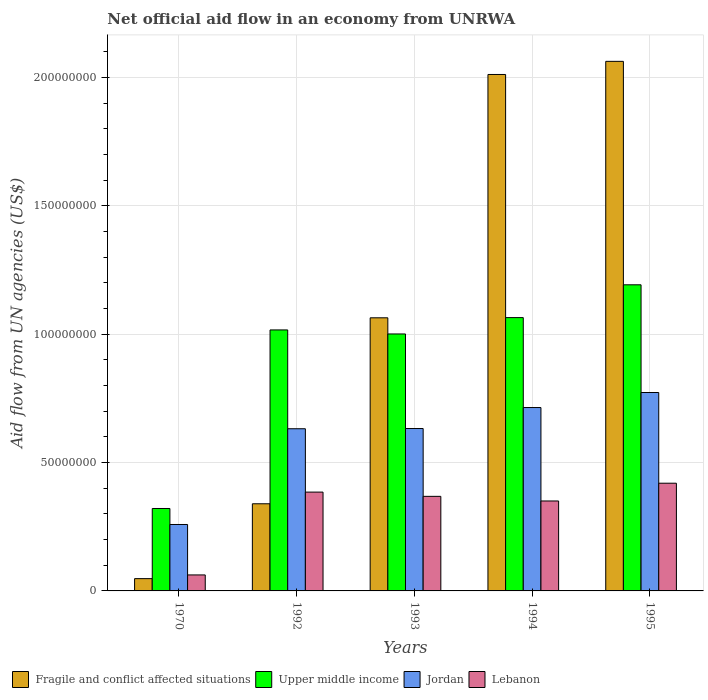Are the number of bars per tick equal to the number of legend labels?
Offer a very short reply. Yes. How many bars are there on the 4th tick from the right?
Provide a succinct answer. 4. What is the net official aid flow in Upper middle income in 1992?
Offer a terse response. 1.02e+08. Across all years, what is the maximum net official aid flow in Lebanon?
Offer a very short reply. 4.20e+07. Across all years, what is the minimum net official aid flow in Upper middle income?
Make the answer very short. 3.21e+07. In which year was the net official aid flow in Jordan maximum?
Provide a succinct answer. 1995. In which year was the net official aid flow in Jordan minimum?
Make the answer very short. 1970. What is the total net official aid flow in Fragile and conflict affected situations in the graph?
Make the answer very short. 5.53e+08. What is the difference between the net official aid flow in Lebanon in 1970 and that in 1992?
Your response must be concise. -3.23e+07. What is the difference between the net official aid flow in Upper middle income in 1970 and the net official aid flow in Jordan in 1995?
Give a very brief answer. -4.52e+07. What is the average net official aid flow in Fragile and conflict affected situations per year?
Offer a terse response. 1.11e+08. In the year 1993, what is the difference between the net official aid flow in Upper middle income and net official aid flow in Jordan?
Offer a terse response. 3.68e+07. What is the ratio of the net official aid flow in Upper middle income in 1970 to that in 1993?
Offer a terse response. 0.32. Is the difference between the net official aid flow in Upper middle income in 1993 and 1995 greater than the difference between the net official aid flow in Jordan in 1993 and 1995?
Offer a terse response. No. What is the difference between the highest and the second highest net official aid flow in Fragile and conflict affected situations?
Give a very brief answer. 5.11e+06. What is the difference between the highest and the lowest net official aid flow in Lebanon?
Ensure brevity in your answer.  3.57e+07. In how many years, is the net official aid flow in Fragile and conflict affected situations greater than the average net official aid flow in Fragile and conflict affected situations taken over all years?
Make the answer very short. 2. Is the sum of the net official aid flow in Upper middle income in 1994 and 1995 greater than the maximum net official aid flow in Lebanon across all years?
Your answer should be compact. Yes. What does the 3rd bar from the left in 1992 represents?
Offer a very short reply. Jordan. What does the 3rd bar from the right in 1994 represents?
Offer a very short reply. Upper middle income. How many bars are there?
Give a very brief answer. 20. Does the graph contain grids?
Your response must be concise. Yes. What is the title of the graph?
Your answer should be very brief. Net official aid flow in an economy from UNRWA. What is the label or title of the Y-axis?
Your response must be concise. Aid flow from UN agencies (US$). What is the Aid flow from UN agencies (US$) of Fragile and conflict affected situations in 1970?
Keep it short and to the point. 4.79e+06. What is the Aid flow from UN agencies (US$) of Upper middle income in 1970?
Offer a very short reply. 3.21e+07. What is the Aid flow from UN agencies (US$) of Jordan in 1970?
Offer a terse response. 2.59e+07. What is the Aid flow from UN agencies (US$) of Lebanon in 1970?
Your answer should be compact. 6.23e+06. What is the Aid flow from UN agencies (US$) in Fragile and conflict affected situations in 1992?
Offer a terse response. 3.40e+07. What is the Aid flow from UN agencies (US$) in Upper middle income in 1992?
Offer a very short reply. 1.02e+08. What is the Aid flow from UN agencies (US$) in Jordan in 1992?
Give a very brief answer. 6.32e+07. What is the Aid flow from UN agencies (US$) in Lebanon in 1992?
Offer a very short reply. 3.85e+07. What is the Aid flow from UN agencies (US$) in Fragile and conflict affected situations in 1993?
Your answer should be compact. 1.06e+08. What is the Aid flow from UN agencies (US$) of Upper middle income in 1993?
Keep it short and to the point. 1.00e+08. What is the Aid flow from UN agencies (US$) of Jordan in 1993?
Provide a short and direct response. 6.33e+07. What is the Aid flow from UN agencies (US$) in Lebanon in 1993?
Ensure brevity in your answer.  3.68e+07. What is the Aid flow from UN agencies (US$) of Fragile and conflict affected situations in 1994?
Your answer should be compact. 2.01e+08. What is the Aid flow from UN agencies (US$) of Upper middle income in 1994?
Offer a very short reply. 1.06e+08. What is the Aid flow from UN agencies (US$) of Jordan in 1994?
Keep it short and to the point. 7.14e+07. What is the Aid flow from UN agencies (US$) of Lebanon in 1994?
Offer a very short reply. 3.50e+07. What is the Aid flow from UN agencies (US$) in Fragile and conflict affected situations in 1995?
Offer a terse response. 2.06e+08. What is the Aid flow from UN agencies (US$) in Upper middle income in 1995?
Offer a terse response. 1.19e+08. What is the Aid flow from UN agencies (US$) in Jordan in 1995?
Make the answer very short. 7.73e+07. What is the Aid flow from UN agencies (US$) in Lebanon in 1995?
Your answer should be compact. 4.20e+07. Across all years, what is the maximum Aid flow from UN agencies (US$) of Fragile and conflict affected situations?
Your answer should be compact. 2.06e+08. Across all years, what is the maximum Aid flow from UN agencies (US$) of Upper middle income?
Provide a short and direct response. 1.19e+08. Across all years, what is the maximum Aid flow from UN agencies (US$) of Jordan?
Your answer should be very brief. 7.73e+07. Across all years, what is the maximum Aid flow from UN agencies (US$) of Lebanon?
Keep it short and to the point. 4.20e+07. Across all years, what is the minimum Aid flow from UN agencies (US$) in Fragile and conflict affected situations?
Ensure brevity in your answer.  4.79e+06. Across all years, what is the minimum Aid flow from UN agencies (US$) in Upper middle income?
Give a very brief answer. 3.21e+07. Across all years, what is the minimum Aid flow from UN agencies (US$) of Jordan?
Provide a short and direct response. 2.59e+07. Across all years, what is the minimum Aid flow from UN agencies (US$) of Lebanon?
Offer a terse response. 6.23e+06. What is the total Aid flow from UN agencies (US$) in Fragile and conflict affected situations in the graph?
Your answer should be very brief. 5.53e+08. What is the total Aid flow from UN agencies (US$) in Upper middle income in the graph?
Give a very brief answer. 4.60e+08. What is the total Aid flow from UN agencies (US$) in Jordan in the graph?
Your answer should be compact. 3.01e+08. What is the total Aid flow from UN agencies (US$) of Lebanon in the graph?
Give a very brief answer. 1.59e+08. What is the difference between the Aid flow from UN agencies (US$) in Fragile and conflict affected situations in 1970 and that in 1992?
Your response must be concise. -2.92e+07. What is the difference between the Aid flow from UN agencies (US$) of Upper middle income in 1970 and that in 1992?
Your answer should be compact. -6.96e+07. What is the difference between the Aid flow from UN agencies (US$) of Jordan in 1970 and that in 1992?
Ensure brevity in your answer.  -3.73e+07. What is the difference between the Aid flow from UN agencies (US$) of Lebanon in 1970 and that in 1992?
Make the answer very short. -3.23e+07. What is the difference between the Aid flow from UN agencies (US$) of Fragile and conflict affected situations in 1970 and that in 1993?
Offer a very short reply. -1.02e+08. What is the difference between the Aid flow from UN agencies (US$) of Upper middle income in 1970 and that in 1993?
Give a very brief answer. -6.80e+07. What is the difference between the Aid flow from UN agencies (US$) in Jordan in 1970 and that in 1993?
Your answer should be compact. -3.74e+07. What is the difference between the Aid flow from UN agencies (US$) of Lebanon in 1970 and that in 1993?
Ensure brevity in your answer.  -3.06e+07. What is the difference between the Aid flow from UN agencies (US$) in Fragile and conflict affected situations in 1970 and that in 1994?
Your response must be concise. -1.96e+08. What is the difference between the Aid flow from UN agencies (US$) in Upper middle income in 1970 and that in 1994?
Make the answer very short. -7.44e+07. What is the difference between the Aid flow from UN agencies (US$) in Jordan in 1970 and that in 1994?
Your answer should be very brief. -4.56e+07. What is the difference between the Aid flow from UN agencies (US$) in Lebanon in 1970 and that in 1994?
Ensure brevity in your answer.  -2.88e+07. What is the difference between the Aid flow from UN agencies (US$) of Fragile and conflict affected situations in 1970 and that in 1995?
Give a very brief answer. -2.02e+08. What is the difference between the Aid flow from UN agencies (US$) in Upper middle income in 1970 and that in 1995?
Provide a short and direct response. -8.72e+07. What is the difference between the Aid flow from UN agencies (US$) of Jordan in 1970 and that in 1995?
Offer a terse response. -5.14e+07. What is the difference between the Aid flow from UN agencies (US$) in Lebanon in 1970 and that in 1995?
Make the answer very short. -3.57e+07. What is the difference between the Aid flow from UN agencies (US$) in Fragile and conflict affected situations in 1992 and that in 1993?
Keep it short and to the point. -7.24e+07. What is the difference between the Aid flow from UN agencies (US$) of Upper middle income in 1992 and that in 1993?
Keep it short and to the point. 1.57e+06. What is the difference between the Aid flow from UN agencies (US$) of Jordan in 1992 and that in 1993?
Ensure brevity in your answer.  -9.00e+04. What is the difference between the Aid flow from UN agencies (US$) of Lebanon in 1992 and that in 1993?
Make the answer very short. 1.66e+06. What is the difference between the Aid flow from UN agencies (US$) in Fragile and conflict affected situations in 1992 and that in 1994?
Offer a terse response. -1.67e+08. What is the difference between the Aid flow from UN agencies (US$) of Upper middle income in 1992 and that in 1994?
Offer a very short reply. -4.80e+06. What is the difference between the Aid flow from UN agencies (US$) of Jordan in 1992 and that in 1994?
Make the answer very short. -8.26e+06. What is the difference between the Aid flow from UN agencies (US$) of Lebanon in 1992 and that in 1994?
Keep it short and to the point. 3.46e+06. What is the difference between the Aid flow from UN agencies (US$) in Fragile and conflict affected situations in 1992 and that in 1995?
Give a very brief answer. -1.72e+08. What is the difference between the Aid flow from UN agencies (US$) in Upper middle income in 1992 and that in 1995?
Ensure brevity in your answer.  -1.76e+07. What is the difference between the Aid flow from UN agencies (US$) in Jordan in 1992 and that in 1995?
Keep it short and to the point. -1.41e+07. What is the difference between the Aid flow from UN agencies (US$) of Lebanon in 1992 and that in 1995?
Your answer should be compact. -3.46e+06. What is the difference between the Aid flow from UN agencies (US$) in Fragile and conflict affected situations in 1993 and that in 1994?
Your response must be concise. -9.48e+07. What is the difference between the Aid flow from UN agencies (US$) in Upper middle income in 1993 and that in 1994?
Your answer should be compact. -6.37e+06. What is the difference between the Aid flow from UN agencies (US$) of Jordan in 1993 and that in 1994?
Your answer should be very brief. -8.17e+06. What is the difference between the Aid flow from UN agencies (US$) in Lebanon in 1993 and that in 1994?
Ensure brevity in your answer.  1.80e+06. What is the difference between the Aid flow from UN agencies (US$) of Fragile and conflict affected situations in 1993 and that in 1995?
Offer a very short reply. -9.99e+07. What is the difference between the Aid flow from UN agencies (US$) of Upper middle income in 1993 and that in 1995?
Make the answer very short. -1.92e+07. What is the difference between the Aid flow from UN agencies (US$) of Jordan in 1993 and that in 1995?
Give a very brief answer. -1.40e+07. What is the difference between the Aid flow from UN agencies (US$) of Lebanon in 1993 and that in 1995?
Offer a terse response. -5.12e+06. What is the difference between the Aid flow from UN agencies (US$) in Fragile and conflict affected situations in 1994 and that in 1995?
Provide a short and direct response. -5.11e+06. What is the difference between the Aid flow from UN agencies (US$) in Upper middle income in 1994 and that in 1995?
Provide a succinct answer. -1.28e+07. What is the difference between the Aid flow from UN agencies (US$) of Jordan in 1994 and that in 1995?
Make the answer very short. -5.86e+06. What is the difference between the Aid flow from UN agencies (US$) of Lebanon in 1994 and that in 1995?
Offer a terse response. -6.92e+06. What is the difference between the Aid flow from UN agencies (US$) in Fragile and conflict affected situations in 1970 and the Aid flow from UN agencies (US$) in Upper middle income in 1992?
Offer a terse response. -9.69e+07. What is the difference between the Aid flow from UN agencies (US$) in Fragile and conflict affected situations in 1970 and the Aid flow from UN agencies (US$) in Jordan in 1992?
Your answer should be compact. -5.84e+07. What is the difference between the Aid flow from UN agencies (US$) in Fragile and conflict affected situations in 1970 and the Aid flow from UN agencies (US$) in Lebanon in 1992?
Offer a terse response. -3.37e+07. What is the difference between the Aid flow from UN agencies (US$) of Upper middle income in 1970 and the Aid flow from UN agencies (US$) of Jordan in 1992?
Your answer should be very brief. -3.11e+07. What is the difference between the Aid flow from UN agencies (US$) of Upper middle income in 1970 and the Aid flow from UN agencies (US$) of Lebanon in 1992?
Offer a terse response. -6.39e+06. What is the difference between the Aid flow from UN agencies (US$) of Jordan in 1970 and the Aid flow from UN agencies (US$) of Lebanon in 1992?
Your answer should be compact. -1.26e+07. What is the difference between the Aid flow from UN agencies (US$) of Fragile and conflict affected situations in 1970 and the Aid flow from UN agencies (US$) of Upper middle income in 1993?
Provide a short and direct response. -9.53e+07. What is the difference between the Aid flow from UN agencies (US$) in Fragile and conflict affected situations in 1970 and the Aid flow from UN agencies (US$) in Jordan in 1993?
Your answer should be very brief. -5.85e+07. What is the difference between the Aid flow from UN agencies (US$) of Fragile and conflict affected situations in 1970 and the Aid flow from UN agencies (US$) of Lebanon in 1993?
Make the answer very short. -3.20e+07. What is the difference between the Aid flow from UN agencies (US$) in Upper middle income in 1970 and the Aid flow from UN agencies (US$) in Jordan in 1993?
Offer a terse response. -3.12e+07. What is the difference between the Aid flow from UN agencies (US$) in Upper middle income in 1970 and the Aid flow from UN agencies (US$) in Lebanon in 1993?
Keep it short and to the point. -4.73e+06. What is the difference between the Aid flow from UN agencies (US$) of Jordan in 1970 and the Aid flow from UN agencies (US$) of Lebanon in 1993?
Ensure brevity in your answer.  -1.10e+07. What is the difference between the Aid flow from UN agencies (US$) in Fragile and conflict affected situations in 1970 and the Aid flow from UN agencies (US$) in Upper middle income in 1994?
Provide a succinct answer. -1.02e+08. What is the difference between the Aid flow from UN agencies (US$) of Fragile and conflict affected situations in 1970 and the Aid flow from UN agencies (US$) of Jordan in 1994?
Provide a succinct answer. -6.66e+07. What is the difference between the Aid flow from UN agencies (US$) in Fragile and conflict affected situations in 1970 and the Aid flow from UN agencies (US$) in Lebanon in 1994?
Your answer should be compact. -3.02e+07. What is the difference between the Aid flow from UN agencies (US$) in Upper middle income in 1970 and the Aid flow from UN agencies (US$) in Jordan in 1994?
Make the answer very short. -3.93e+07. What is the difference between the Aid flow from UN agencies (US$) of Upper middle income in 1970 and the Aid flow from UN agencies (US$) of Lebanon in 1994?
Your answer should be compact. -2.93e+06. What is the difference between the Aid flow from UN agencies (US$) of Jordan in 1970 and the Aid flow from UN agencies (US$) of Lebanon in 1994?
Provide a short and direct response. -9.16e+06. What is the difference between the Aid flow from UN agencies (US$) of Fragile and conflict affected situations in 1970 and the Aid flow from UN agencies (US$) of Upper middle income in 1995?
Your answer should be very brief. -1.14e+08. What is the difference between the Aid flow from UN agencies (US$) of Fragile and conflict affected situations in 1970 and the Aid flow from UN agencies (US$) of Jordan in 1995?
Give a very brief answer. -7.25e+07. What is the difference between the Aid flow from UN agencies (US$) of Fragile and conflict affected situations in 1970 and the Aid flow from UN agencies (US$) of Lebanon in 1995?
Offer a very short reply. -3.72e+07. What is the difference between the Aid flow from UN agencies (US$) of Upper middle income in 1970 and the Aid flow from UN agencies (US$) of Jordan in 1995?
Offer a terse response. -4.52e+07. What is the difference between the Aid flow from UN agencies (US$) in Upper middle income in 1970 and the Aid flow from UN agencies (US$) in Lebanon in 1995?
Offer a very short reply. -9.85e+06. What is the difference between the Aid flow from UN agencies (US$) in Jordan in 1970 and the Aid flow from UN agencies (US$) in Lebanon in 1995?
Provide a short and direct response. -1.61e+07. What is the difference between the Aid flow from UN agencies (US$) of Fragile and conflict affected situations in 1992 and the Aid flow from UN agencies (US$) of Upper middle income in 1993?
Ensure brevity in your answer.  -6.62e+07. What is the difference between the Aid flow from UN agencies (US$) of Fragile and conflict affected situations in 1992 and the Aid flow from UN agencies (US$) of Jordan in 1993?
Make the answer very short. -2.93e+07. What is the difference between the Aid flow from UN agencies (US$) of Fragile and conflict affected situations in 1992 and the Aid flow from UN agencies (US$) of Lebanon in 1993?
Your answer should be compact. -2.89e+06. What is the difference between the Aid flow from UN agencies (US$) in Upper middle income in 1992 and the Aid flow from UN agencies (US$) in Jordan in 1993?
Provide a succinct answer. 3.84e+07. What is the difference between the Aid flow from UN agencies (US$) in Upper middle income in 1992 and the Aid flow from UN agencies (US$) in Lebanon in 1993?
Provide a short and direct response. 6.48e+07. What is the difference between the Aid flow from UN agencies (US$) of Jordan in 1992 and the Aid flow from UN agencies (US$) of Lebanon in 1993?
Provide a succinct answer. 2.63e+07. What is the difference between the Aid flow from UN agencies (US$) in Fragile and conflict affected situations in 1992 and the Aid flow from UN agencies (US$) in Upper middle income in 1994?
Provide a succinct answer. -7.25e+07. What is the difference between the Aid flow from UN agencies (US$) in Fragile and conflict affected situations in 1992 and the Aid flow from UN agencies (US$) in Jordan in 1994?
Make the answer very short. -3.75e+07. What is the difference between the Aid flow from UN agencies (US$) of Fragile and conflict affected situations in 1992 and the Aid flow from UN agencies (US$) of Lebanon in 1994?
Offer a terse response. -1.09e+06. What is the difference between the Aid flow from UN agencies (US$) in Upper middle income in 1992 and the Aid flow from UN agencies (US$) in Jordan in 1994?
Make the answer very short. 3.02e+07. What is the difference between the Aid flow from UN agencies (US$) in Upper middle income in 1992 and the Aid flow from UN agencies (US$) in Lebanon in 1994?
Provide a short and direct response. 6.66e+07. What is the difference between the Aid flow from UN agencies (US$) in Jordan in 1992 and the Aid flow from UN agencies (US$) in Lebanon in 1994?
Provide a succinct answer. 2.81e+07. What is the difference between the Aid flow from UN agencies (US$) in Fragile and conflict affected situations in 1992 and the Aid flow from UN agencies (US$) in Upper middle income in 1995?
Your answer should be very brief. -8.53e+07. What is the difference between the Aid flow from UN agencies (US$) in Fragile and conflict affected situations in 1992 and the Aid flow from UN agencies (US$) in Jordan in 1995?
Give a very brief answer. -4.34e+07. What is the difference between the Aid flow from UN agencies (US$) of Fragile and conflict affected situations in 1992 and the Aid flow from UN agencies (US$) of Lebanon in 1995?
Your answer should be compact. -8.01e+06. What is the difference between the Aid flow from UN agencies (US$) in Upper middle income in 1992 and the Aid flow from UN agencies (US$) in Jordan in 1995?
Keep it short and to the point. 2.44e+07. What is the difference between the Aid flow from UN agencies (US$) of Upper middle income in 1992 and the Aid flow from UN agencies (US$) of Lebanon in 1995?
Offer a terse response. 5.97e+07. What is the difference between the Aid flow from UN agencies (US$) of Jordan in 1992 and the Aid flow from UN agencies (US$) of Lebanon in 1995?
Keep it short and to the point. 2.12e+07. What is the difference between the Aid flow from UN agencies (US$) of Fragile and conflict affected situations in 1993 and the Aid flow from UN agencies (US$) of Upper middle income in 1994?
Give a very brief answer. -8.00e+04. What is the difference between the Aid flow from UN agencies (US$) of Fragile and conflict affected situations in 1993 and the Aid flow from UN agencies (US$) of Jordan in 1994?
Your answer should be very brief. 3.50e+07. What is the difference between the Aid flow from UN agencies (US$) of Fragile and conflict affected situations in 1993 and the Aid flow from UN agencies (US$) of Lebanon in 1994?
Provide a short and direct response. 7.14e+07. What is the difference between the Aid flow from UN agencies (US$) of Upper middle income in 1993 and the Aid flow from UN agencies (US$) of Jordan in 1994?
Your response must be concise. 2.87e+07. What is the difference between the Aid flow from UN agencies (US$) of Upper middle income in 1993 and the Aid flow from UN agencies (US$) of Lebanon in 1994?
Your answer should be compact. 6.51e+07. What is the difference between the Aid flow from UN agencies (US$) in Jordan in 1993 and the Aid flow from UN agencies (US$) in Lebanon in 1994?
Your answer should be compact. 2.82e+07. What is the difference between the Aid flow from UN agencies (US$) of Fragile and conflict affected situations in 1993 and the Aid flow from UN agencies (US$) of Upper middle income in 1995?
Offer a very short reply. -1.29e+07. What is the difference between the Aid flow from UN agencies (US$) of Fragile and conflict affected situations in 1993 and the Aid flow from UN agencies (US$) of Jordan in 1995?
Give a very brief answer. 2.91e+07. What is the difference between the Aid flow from UN agencies (US$) of Fragile and conflict affected situations in 1993 and the Aid flow from UN agencies (US$) of Lebanon in 1995?
Keep it short and to the point. 6.44e+07. What is the difference between the Aid flow from UN agencies (US$) of Upper middle income in 1993 and the Aid flow from UN agencies (US$) of Jordan in 1995?
Ensure brevity in your answer.  2.28e+07. What is the difference between the Aid flow from UN agencies (US$) of Upper middle income in 1993 and the Aid flow from UN agencies (US$) of Lebanon in 1995?
Keep it short and to the point. 5.82e+07. What is the difference between the Aid flow from UN agencies (US$) of Jordan in 1993 and the Aid flow from UN agencies (US$) of Lebanon in 1995?
Provide a short and direct response. 2.13e+07. What is the difference between the Aid flow from UN agencies (US$) of Fragile and conflict affected situations in 1994 and the Aid flow from UN agencies (US$) of Upper middle income in 1995?
Ensure brevity in your answer.  8.19e+07. What is the difference between the Aid flow from UN agencies (US$) of Fragile and conflict affected situations in 1994 and the Aid flow from UN agencies (US$) of Jordan in 1995?
Keep it short and to the point. 1.24e+08. What is the difference between the Aid flow from UN agencies (US$) of Fragile and conflict affected situations in 1994 and the Aid flow from UN agencies (US$) of Lebanon in 1995?
Offer a very short reply. 1.59e+08. What is the difference between the Aid flow from UN agencies (US$) in Upper middle income in 1994 and the Aid flow from UN agencies (US$) in Jordan in 1995?
Your response must be concise. 2.92e+07. What is the difference between the Aid flow from UN agencies (US$) in Upper middle income in 1994 and the Aid flow from UN agencies (US$) in Lebanon in 1995?
Offer a very short reply. 6.45e+07. What is the difference between the Aid flow from UN agencies (US$) of Jordan in 1994 and the Aid flow from UN agencies (US$) of Lebanon in 1995?
Give a very brief answer. 2.95e+07. What is the average Aid flow from UN agencies (US$) in Fragile and conflict affected situations per year?
Give a very brief answer. 1.11e+08. What is the average Aid flow from UN agencies (US$) in Upper middle income per year?
Your response must be concise. 9.19e+07. What is the average Aid flow from UN agencies (US$) of Jordan per year?
Your answer should be very brief. 6.02e+07. What is the average Aid flow from UN agencies (US$) in Lebanon per year?
Ensure brevity in your answer.  3.17e+07. In the year 1970, what is the difference between the Aid flow from UN agencies (US$) of Fragile and conflict affected situations and Aid flow from UN agencies (US$) of Upper middle income?
Make the answer very short. -2.73e+07. In the year 1970, what is the difference between the Aid flow from UN agencies (US$) of Fragile and conflict affected situations and Aid flow from UN agencies (US$) of Jordan?
Provide a succinct answer. -2.11e+07. In the year 1970, what is the difference between the Aid flow from UN agencies (US$) in Fragile and conflict affected situations and Aid flow from UN agencies (US$) in Lebanon?
Your response must be concise. -1.44e+06. In the year 1970, what is the difference between the Aid flow from UN agencies (US$) of Upper middle income and Aid flow from UN agencies (US$) of Jordan?
Your answer should be very brief. 6.23e+06. In the year 1970, what is the difference between the Aid flow from UN agencies (US$) in Upper middle income and Aid flow from UN agencies (US$) in Lebanon?
Provide a succinct answer. 2.59e+07. In the year 1970, what is the difference between the Aid flow from UN agencies (US$) of Jordan and Aid flow from UN agencies (US$) of Lebanon?
Your answer should be very brief. 1.96e+07. In the year 1992, what is the difference between the Aid flow from UN agencies (US$) in Fragile and conflict affected situations and Aid flow from UN agencies (US$) in Upper middle income?
Provide a short and direct response. -6.77e+07. In the year 1992, what is the difference between the Aid flow from UN agencies (US$) of Fragile and conflict affected situations and Aid flow from UN agencies (US$) of Jordan?
Give a very brief answer. -2.92e+07. In the year 1992, what is the difference between the Aid flow from UN agencies (US$) of Fragile and conflict affected situations and Aid flow from UN agencies (US$) of Lebanon?
Ensure brevity in your answer.  -4.55e+06. In the year 1992, what is the difference between the Aid flow from UN agencies (US$) of Upper middle income and Aid flow from UN agencies (US$) of Jordan?
Your response must be concise. 3.85e+07. In the year 1992, what is the difference between the Aid flow from UN agencies (US$) of Upper middle income and Aid flow from UN agencies (US$) of Lebanon?
Ensure brevity in your answer.  6.32e+07. In the year 1992, what is the difference between the Aid flow from UN agencies (US$) in Jordan and Aid flow from UN agencies (US$) in Lebanon?
Ensure brevity in your answer.  2.47e+07. In the year 1993, what is the difference between the Aid flow from UN agencies (US$) in Fragile and conflict affected situations and Aid flow from UN agencies (US$) in Upper middle income?
Make the answer very short. 6.29e+06. In the year 1993, what is the difference between the Aid flow from UN agencies (US$) in Fragile and conflict affected situations and Aid flow from UN agencies (US$) in Jordan?
Your response must be concise. 4.31e+07. In the year 1993, what is the difference between the Aid flow from UN agencies (US$) of Fragile and conflict affected situations and Aid flow from UN agencies (US$) of Lebanon?
Make the answer very short. 6.96e+07. In the year 1993, what is the difference between the Aid flow from UN agencies (US$) of Upper middle income and Aid flow from UN agencies (US$) of Jordan?
Your answer should be compact. 3.68e+07. In the year 1993, what is the difference between the Aid flow from UN agencies (US$) of Upper middle income and Aid flow from UN agencies (US$) of Lebanon?
Keep it short and to the point. 6.33e+07. In the year 1993, what is the difference between the Aid flow from UN agencies (US$) of Jordan and Aid flow from UN agencies (US$) of Lebanon?
Your answer should be compact. 2.64e+07. In the year 1994, what is the difference between the Aid flow from UN agencies (US$) in Fragile and conflict affected situations and Aid flow from UN agencies (US$) in Upper middle income?
Make the answer very short. 9.47e+07. In the year 1994, what is the difference between the Aid flow from UN agencies (US$) in Fragile and conflict affected situations and Aid flow from UN agencies (US$) in Jordan?
Provide a short and direct response. 1.30e+08. In the year 1994, what is the difference between the Aid flow from UN agencies (US$) of Fragile and conflict affected situations and Aid flow from UN agencies (US$) of Lebanon?
Your answer should be compact. 1.66e+08. In the year 1994, what is the difference between the Aid flow from UN agencies (US$) in Upper middle income and Aid flow from UN agencies (US$) in Jordan?
Offer a very short reply. 3.50e+07. In the year 1994, what is the difference between the Aid flow from UN agencies (US$) of Upper middle income and Aid flow from UN agencies (US$) of Lebanon?
Keep it short and to the point. 7.14e+07. In the year 1994, what is the difference between the Aid flow from UN agencies (US$) in Jordan and Aid flow from UN agencies (US$) in Lebanon?
Give a very brief answer. 3.64e+07. In the year 1995, what is the difference between the Aid flow from UN agencies (US$) in Fragile and conflict affected situations and Aid flow from UN agencies (US$) in Upper middle income?
Your response must be concise. 8.70e+07. In the year 1995, what is the difference between the Aid flow from UN agencies (US$) in Fragile and conflict affected situations and Aid flow from UN agencies (US$) in Jordan?
Offer a very short reply. 1.29e+08. In the year 1995, what is the difference between the Aid flow from UN agencies (US$) in Fragile and conflict affected situations and Aid flow from UN agencies (US$) in Lebanon?
Provide a short and direct response. 1.64e+08. In the year 1995, what is the difference between the Aid flow from UN agencies (US$) of Upper middle income and Aid flow from UN agencies (US$) of Jordan?
Your response must be concise. 4.20e+07. In the year 1995, what is the difference between the Aid flow from UN agencies (US$) in Upper middle income and Aid flow from UN agencies (US$) in Lebanon?
Your response must be concise. 7.73e+07. In the year 1995, what is the difference between the Aid flow from UN agencies (US$) in Jordan and Aid flow from UN agencies (US$) in Lebanon?
Your answer should be compact. 3.53e+07. What is the ratio of the Aid flow from UN agencies (US$) in Fragile and conflict affected situations in 1970 to that in 1992?
Keep it short and to the point. 0.14. What is the ratio of the Aid flow from UN agencies (US$) of Upper middle income in 1970 to that in 1992?
Your response must be concise. 0.32. What is the ratio of the Aid flow from UN agencies (US$) in Jordan in 1970 to that in 1992?
Your response must be concise. 0.41. What is the ratio of the Aid flow from UN agencies (US$) in Lebanon in 1970 to that in 1992?
Provide a succinct answer. 0.16. What is the ratio of the Aid flow from UN agencies (US$) in Fragile and conflict affected situations in 1970 to that in 1993?
Keep it short and to the point. 0.04. What is the ratio of the Aid flow from UN agencies (US$) in Upper middle income in 1970 to that in 1993?
Give a very brief answer. 0.32. What is the ratio of the Aid flow from UN agencies (US$) in Jordan in 1970 to that in 1993?
Your answer should be compact. 0.41. What is the ratio of the Aid flow from UN agencies (US$) in Lebanon in 1970 to that in 1993?
Provide a succinct answer. 0.17. What is the ratio of the Aid flow from UN agencies (US$) in Fragile and conflict affected situations in 1970 to that in 1994?
Offer a very short reply. 0.02. What is the ratio of the Aid flow from UN agencies (US$) in Upper middle income in 1970 to that in 1994?
Provide a succinct answer. 0.3. What is the ratio of the Aid flow from UN agencies (US$) of Jordan in 1970 to that in 1994?
Your answer should be compact. 0.36. What is the ratio of the Aid flow from UN agencies (US$) in Lebanon in 1970 to that in 1994?
Provide a succinct answer. 0.18. What is the ratio of the Aid flow from UN agencies (US$) in Fragile and conflict affected situations in 1970 to that in 1995?
Your answer should be compact. 0.02. What is the ratio of the Aid flow from UN agencies (US$) in Upper middle income in 1970 to that in 1995?
Give a very brief answer. 0.27. What is the ratio of the Aid flow from UN agencies (US$) in Jordan in 1970 to that in 1995?
Your answer should be compact. 0.33. What is the ratio of the Aid flow from UN agencies (US$) of Lebanon in 1970 to that in 1995?
Ensure brevity in your answer.  0.15. What is the ratio of the Aid flow from UN agencies (US$) in Fragile and conflict affected situations in 1992 to that in 1993?
Provide a short and direct response. 0.32. What is the ratio of the Aid flow from UN agencies (US$) of Upper middle income in 1992 to that in 1993?
Offer a very short reply. 1.02. What is the ratio of the Aid flow from UN agencies (US$) in Lebanon in 1992 to that in 1993?
Offer a very short reply. 1.05. What is the ratio of the Aid flow from UN agencies (US$) of Fragile and conflict affected situations in 1992 to that in 1994?
Provide a succinct answer. 0.17. What is the ratio of the Aid flow from UN agencies (US$) in Upper middle income in 1992 to that in 1994?
Provide a short and direct response. 0.95. What is the ratio of the Aid flow from UN agencies (US$) of Jordan in 1992 to that in 1994?
Keep it short and to the point. 0.88. What is the ratio of the Aid flow from UN agencies (US$) of Lebanon in 1992 to that in 1994?
Your answer should be compact. 1.1. What is the ratio of the Aid flow from UN agencies (US$) in Fragile and conflict affected situations in 1992 to that in 1995?
Your answer should be very brief. 0.16. What is the ratio of the Aid flow from UN agencies (US$) of Upper middle income in 1992 to that in 1995?
Your response must be concise. 0.85. What is the ratio of the Aid flow from UN agencies (US$) of Jordan in 1992 to that in 1995?
Provide a succinct answer. 0.82. What is the ratio of the Aid flow from UN agencies (US$) in Lebanon in 1992 to that in 1995?
Ensure brevity in your answer.  0.92. What is the ratio of the Aid flow from UN agencies (US$) in Fragile and conflict affected situations in 1993 to that in 1994?
Make the answer very short. 0.53. What is the ratio of the Aid flow from UN agencies (US$) of Upper middle income in 1993 to that in 1994?
Ensure brevity in your answer.  0.94. What is the ratio of the Aid flow from UN agencies (US$) of Jordan in 1993 to that in 1994?
Your response must be concise. 0.89. What is the ratio of the Aid flow from UN agencies (US$) in Lebanon in 1993 to that in 1994?
Provide a succinct answer. 1.05. What is the ratio of the Aid flow from UN agencies (US$) in Fragile and conflict affected situations in 1993 to that in 1995?
Offer a very short reply. 0.52. What is the ratio of the Aid flow from UN agencies (US$) in Upper middle income in 1993 to that in 1995?
Offer a terse response. 0.84. What is the ratio of the Aid flow from UN agencies (US$) of Jordan in 1993 to that in 1995?
Offer a terse response. 0.82. What is the ratio of the Aid flow from UN agencies (US$) in Lebanon in 1993 to that in 1995?
Offer a terse response. 0.88. What is the ratio of the Aid flow from UN agencies (US$) in Fragile and conflict affected situations in 1994 to that in 1995?
Provide a short and direct response. 0.98. What is the ratio of the Aid flow from UN agencies (US$) in Upper middle income in 1994 to that in 1995?
Offer a terse response. 0.89. What is the ratio of the Aid flow from UN agencies (US$) of Jordan in 1994 to that in 1995?
Provide a succinct answer. 0.92. What is the ratio of the Aid flow from UN agencies (US$) of Lebanon in 1994 to that in 1995?
Provide a short and direct response. 0.84. What is the difference between the highest and the second highest Aid flow from UN agencies (US$) of Fragile and conflict affected situations?
Offer a terse response. 5.11e+06. What is the difference between the highest and the second highest Aid flow from UN agencies (US$) of Upper middle income?
Ensure brevity in your answer.  1.28e+07. What is the difference between the highest and the second highest Aid flow from UN agencies (US$) of Jordan?
Your answer should be very brief. 5.86e+06. What is the difference between the highest and the second highest Aid flow from UN agencies (US$) in Lebanon?
Your answer should be compact. 3.46e+06. What is the difference between the highest and the lowest Aid flow from UN agencies (US$) in Fragile and conflict affected situations?
Your answer should be very brief. 2.02e+08. What is the difference between the highest and the lowest Aid flow from UN agencies (US$) of Upper middle income?
Make the answer very short. 8.72e+07. What is the difference between the highest and the lowest Aid flow from UN agencies (US$) in Jordan?
Offer a terse response. 5.14e+07. What is the difference between the highest and the lowest Aid flow from UN agencies (US$) in Lebanon?
Your answer should be compact. 3.57e+07. 